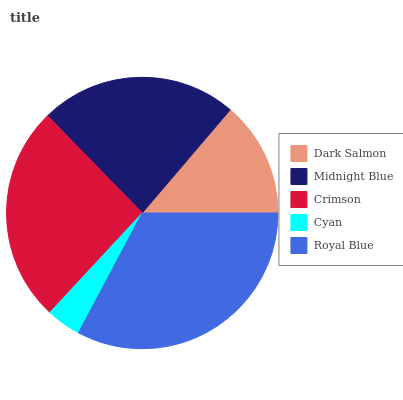Is Cyan the minimum?
Answer yes or no. Yes. Is Royal Blue the maximum?
Answer yes or no. Yes. Is Midnight Blue the minimum?
Answer yes or no. No. Is Midnight Blue the maximum?
Answer yes or no. No. Is Midnight Blue greater than Dark Salmon?
Answer yes or no. Yes. Is Dark Salmon less than Midnight Blue?
Answer yes or no. Yes. Is Dark Salmon greater than Midnight Blue?
Answer yes or no. No. Is Midnight Blue less than Dark Salmon?
Answer yes or no. No. Is Midnight Blue the high median?
Answer yes or no. Yes. Is Midnight Blue the low median?
Answer yes or no. Yes. Is Crimson the high median?
Answer yes or no. No. Is Cyan the low median?
Answer yes or no. No. 